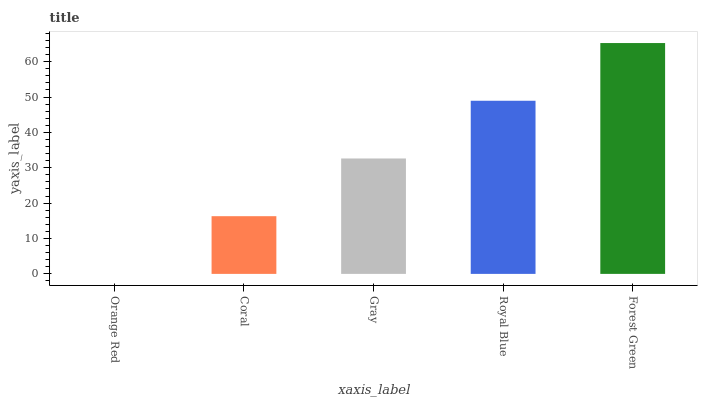Is Orange Red the minimum?
Answer yes or no. Yes. Is Forest Green the maximum?
Answer yes or no. Yes. Is Coral the minimum?
Answer yes or no. No. Is Coral the maximum?
Answer yes or no. No. Is Coral greater than Orange Red?
Answer yes or no. Yes. Is Orange Red less than Coral?
Answer yes or no. Yes. Is Orange Red greater than Coral?
Answer yes or no. No. Is Coral less than Orange Red?
Answer yes or no. No. Is Gray the high median?
Answer yes or no. Yes. Is Gray the low median?
Answer yes or no. Yes. Is Coral the high median?
Answer yes or no. No. Is Coral the low median?
Answer yes or no. No. 